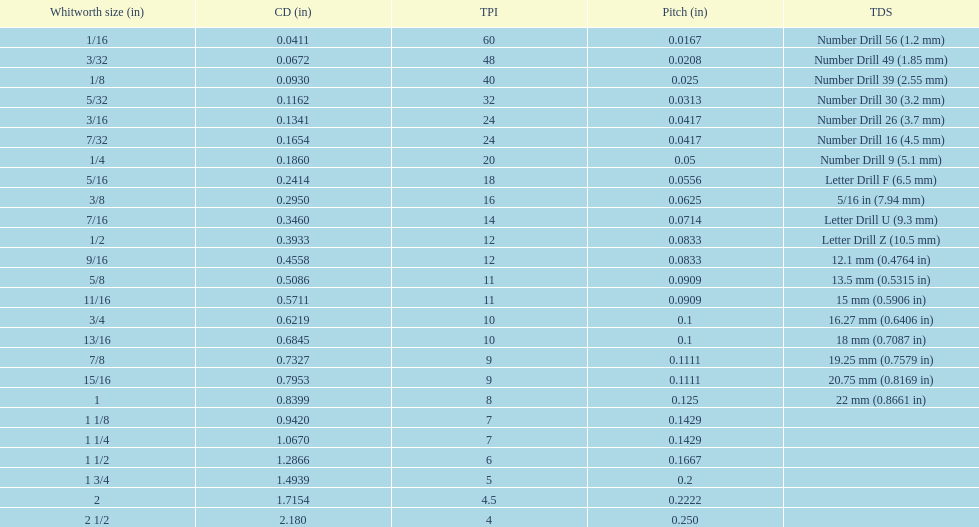Does any whitworth size have the same core diameter as the number drill 26? 3/16. 